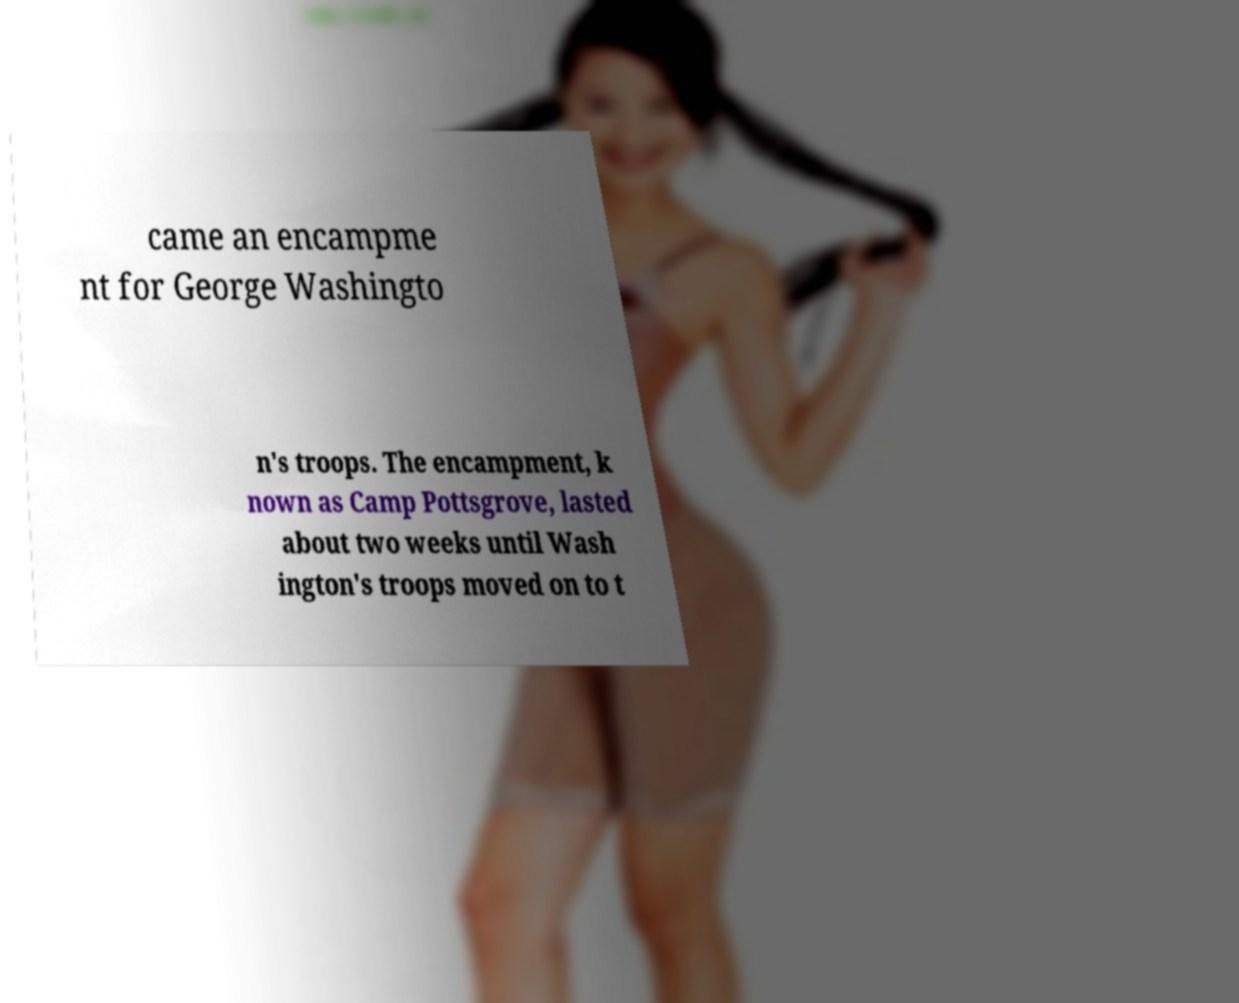Could you assist in decoding the text presented in this image and type it out clearly? came an encampme nt for George Washingto n's troops. The encampment, k nown as Camp Pottsgrove, lasted about two weeks until Wash ington's troops moved on to t 